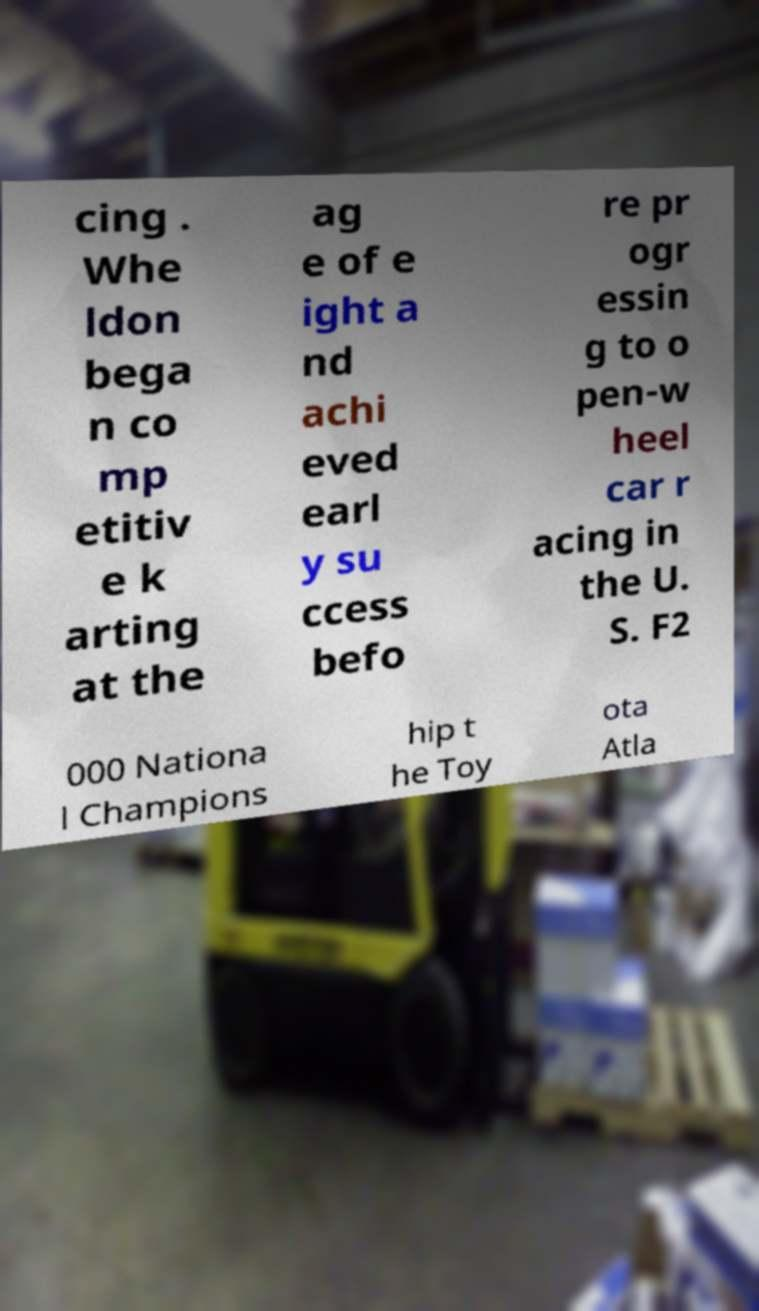Can you accurately transcribe the text from the provided image for me? cing . Whe ldon bega n co mp etitiv e k arting at the ag e of e ight a nd achi eved earl y su ccess befo re pr ogr essin g to o pen-w heel car r acing in the U. S. F2 000 Nationa l Champions hip t he Toy ota Atla 